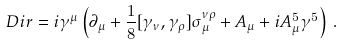Convert formula to latex. <formula><loc_0><loc_0><loc_500><loc_500>\ D i r = i \gamma ^ { \mu } \left ( \partial _ { \mu } + \frac { 1 } { 8 } [ \gamma _ { \nu } , \gamma _ { \rho } ] \sigma _ { \mu } ^ { \nu \rho } + A _ { \mu } + i A _ { \mu } ^ { 5 } \gamma ^ { 5 } \right ) \, .</formula> 